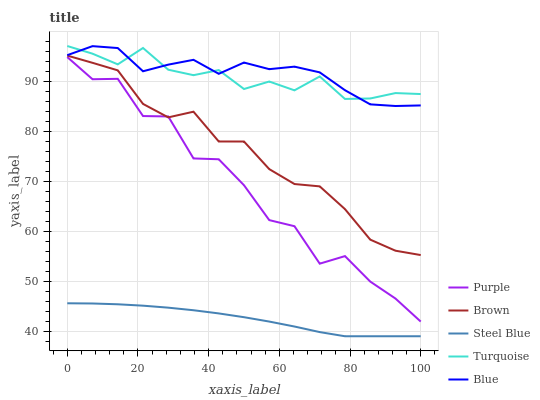Does Steel Blue have the minimum area under the curve?
Answer yes or no. Yes. Does Blue have the maximum area under the curve?
Answer yes or no. Yes. Does Brown have the minimum area under the curve?
Answer yes or no. No. Does Brown have the maximum area under the curve?
Answer yes or no. No. Is Steel Blue the smoothest?
Answer yes or no. Yes. Is Purple the roughest?
Answer yes or no. Yes. Is Brown the smoothest?
Answer yes or no. No. Is Brown the roughest?
Answer yes or no. No. Does Steel Blue have the lowest value?
Answer yes or no. Yes. Does Brown have the lowest value?
Answer yes or no. No. Does Turquoise have the highest value?
Answer yes or no. Yes. Does Brown have the highest value?
Answer yes or no. No. Is Purple less than Blue?
Answer yes or no. Yes. Is Turquoise greater than Purple?
Answer yes or no. Yes. Does Brown intersect Purple?
Answer yes or no. Yes. Is Brown less than Purple?
Answer yes or no. No. Is Brown greater than Purple?
Answer yes or no. No. Does Purple intersect Blue?
Answer yes or no. No. 